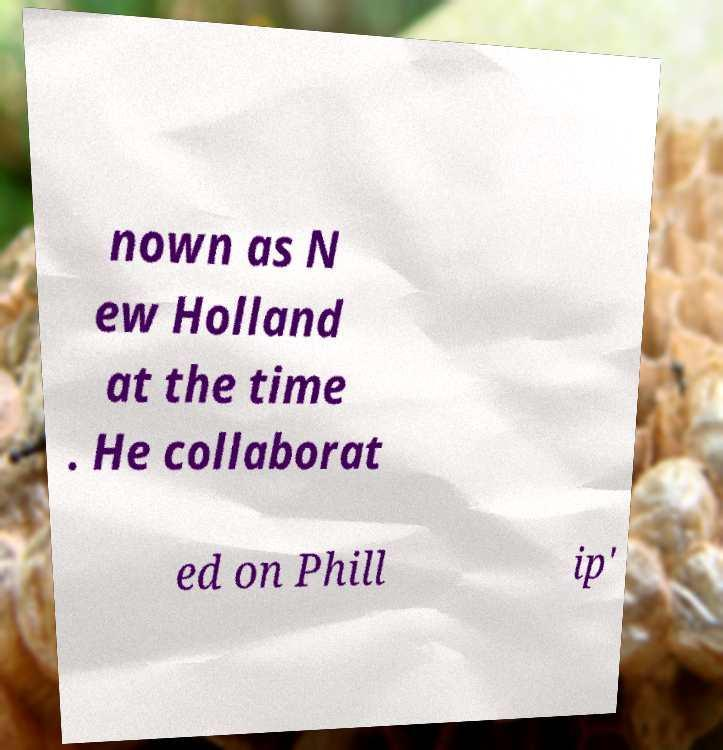What messages or text are displayed in this image? I need them in a readable, typed format. nown as N ew Holland at the time . He collaborat ed on Phill ip' 